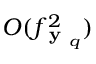<formula> <loc_0><loc_0><loc_500><loc_500>O ( f _ { y _ { q } } ^ { 2 } )</formula> 